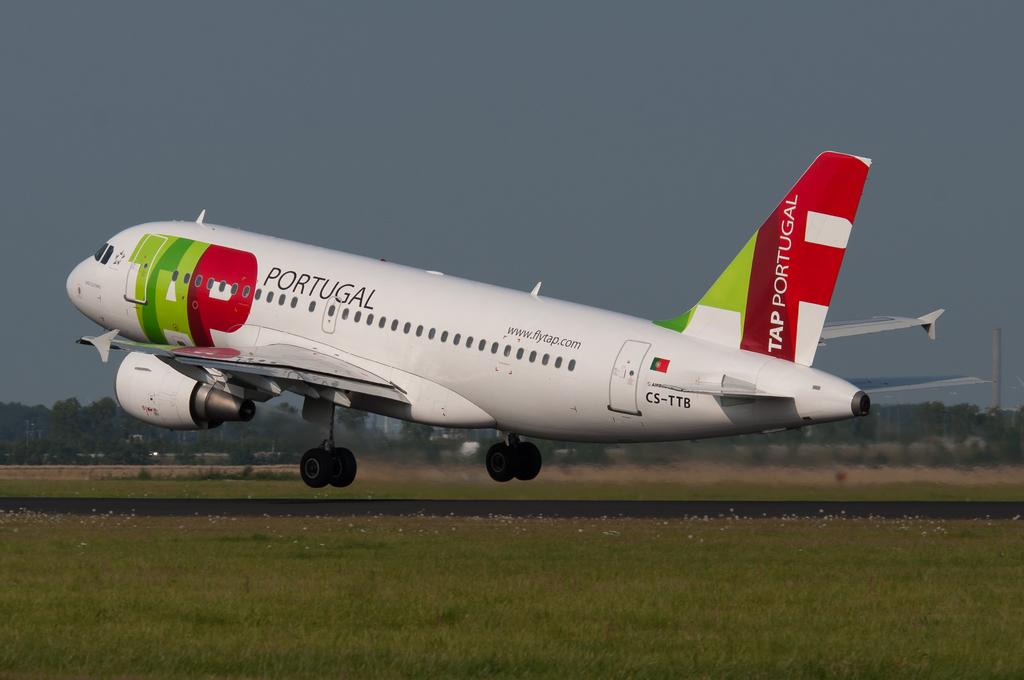What is the main subject of the image? The main subject of the image is an aeroplane flying. Where is the aeroplane located in the image? The aeroplane is in the center of the image. What type of terrain is visible at the bottom of the image? There is grass and a runway visible at the bottom of the image. What can be seen in the background of the image? There are trees and the sky visible in the background of the image. What type of badge is the aeroplane wearing on its wing in the image? There is no badge visible on the aeroplane's wing in the image. How many times does the aeroplane cough while flying in the image? Airplanes do not cough, as they are inanimate objects. 